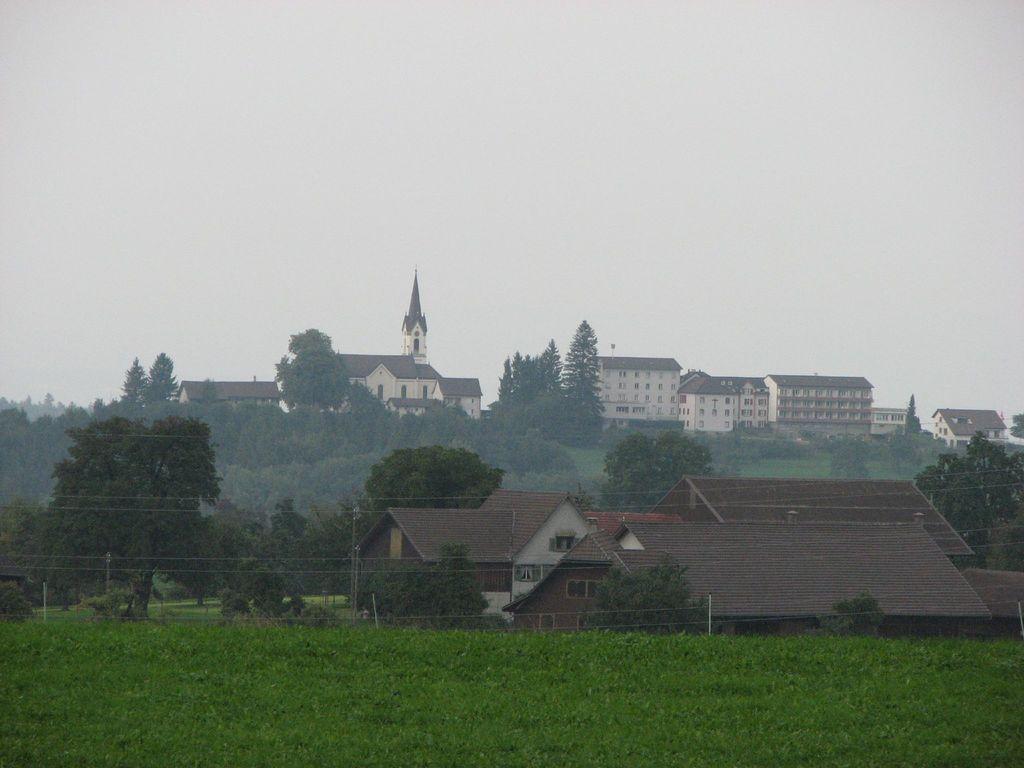Describe this image in one or two sentences. In this image we can see a group of buildings and trees. In the foreground we can see the plants and poles with wires. At the top we can see the sky. 